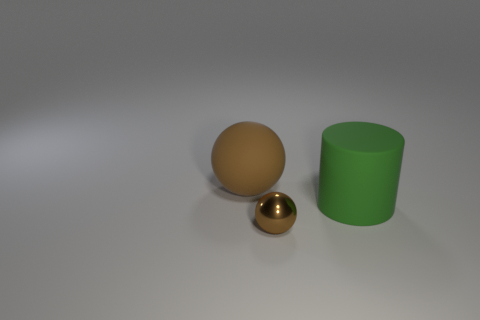There is a large brown thing; what shape is it?
Keep it short and to the point. Sphere. What size is the matte thing that is the same color as the metal thing?
Make the answer very short. Large. There is a brown ball that is in front of the rubber object that is to the left of the small brown object; how big is it?
Keep it short and to the point. Small. How big is the brown thing that is in front of the big matte sphere?
Keep it short and to the point. Small. Is the number of brown balls in front of the brown metal thing less than the number of large green rubber things on the right side of the rubber sphere?
Provide a succinct answer. Yes. The big matte sphere has what color?
Ensure brevity in your answer.  Brown. Are there any tiny matte cubes that have the same color as the tiny sphere?
Offer a terse response. No. There is a rubber object that is behind the large object in front of the big object to the left of the small object; what shape is it?
Provide a succinct answer. Sphere. There is a sphere that is left of the brown metal sphere; what material is it?
Give a very brief answer. Rubber. How big is the brown thing that is behind the green matte cylinder in front of the brown sphere left of the metallic sphere?
Give a very brief answer. Large. 